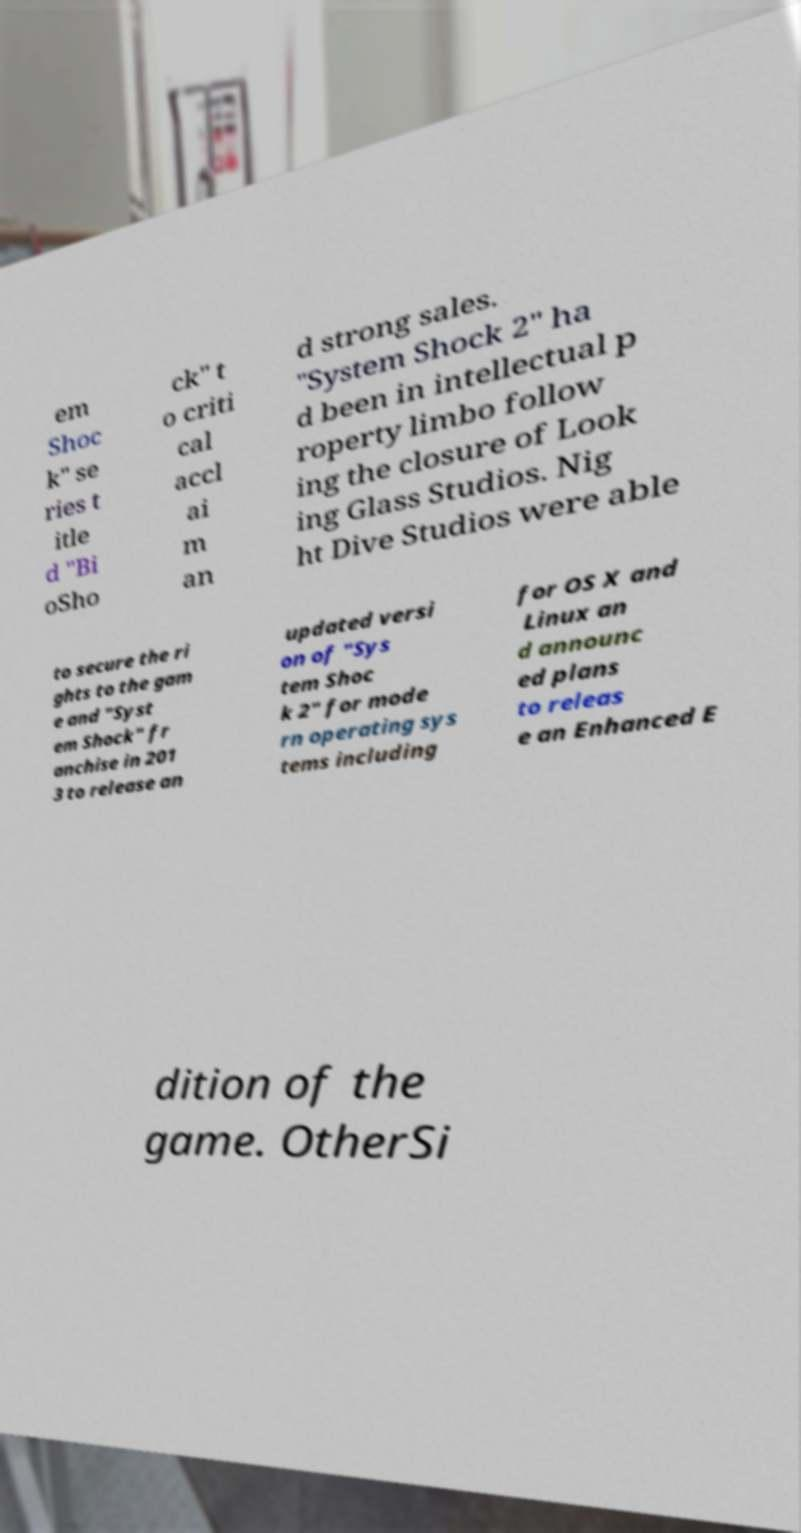Please read and relay the text visible in this image. What does it say? em Shoc k" se ries t itle d "Bi oSho ck" t o criti cal accl ai m an d strong sales. "System Shock 2" ha d been in intellectual p roperty limbo follow ing the closure of Look ing Glass Studios. Nig ht Dive Studios were able to secure the ri ghts to the gam e and "Syst em Shock" fr anchise in 201 3 to release an updated versi on of "Sys tem Shoc k 2" for mode rn operating sys tems including for OS X and Linux an d announc ed plans to releas e an Enhanced E dition of the game. OtherSi 